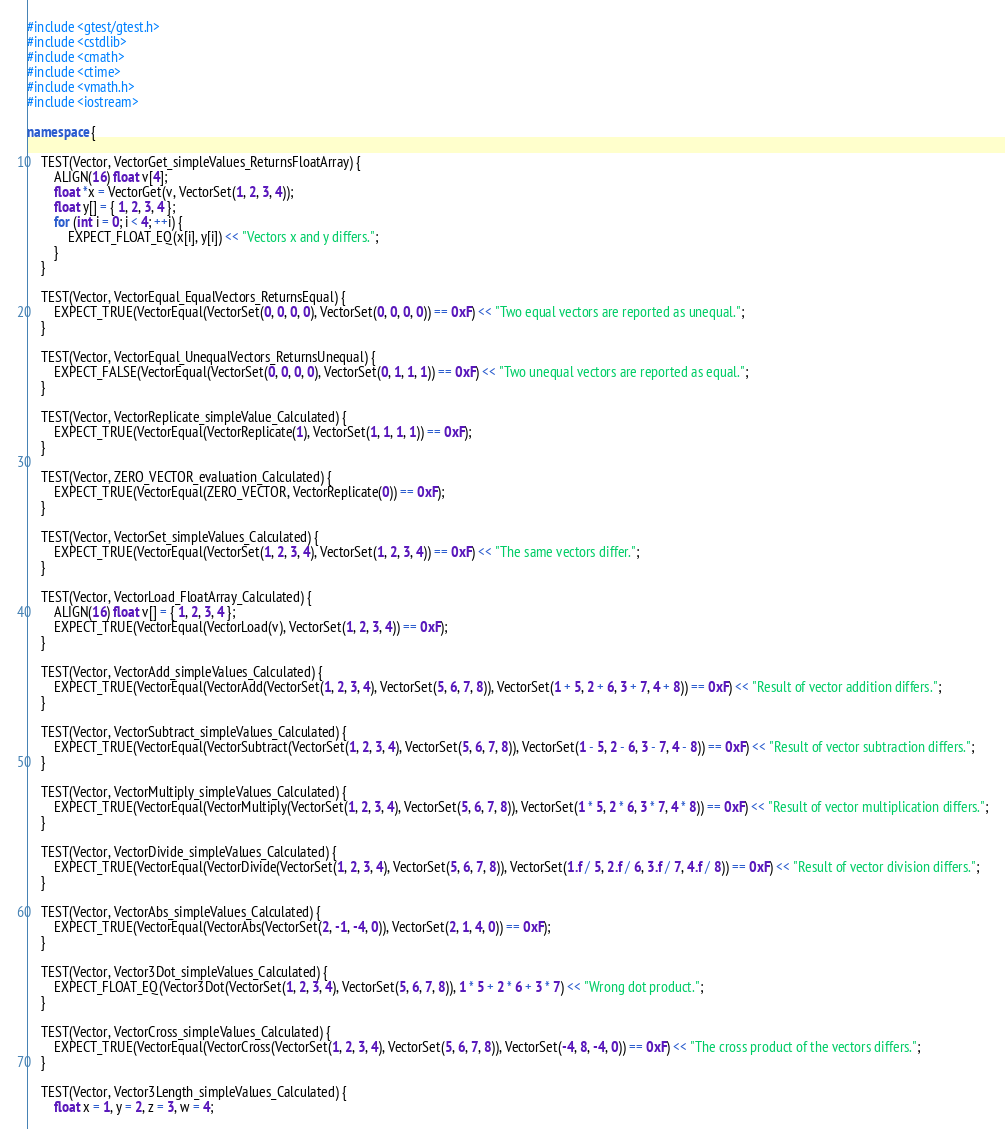Convert code to text. <code><loc_0><loc_0><loc_500><loc_500><_C++_>#include <gtest/gtest.h>
#include <cstdlib>
#include <cmath>
#include <ctime>
#include <vmath.h>
#include <iostream>

namespace {

	TEST(Vector, VectorGet_simpleValues_ReturnsFloatArray) {
		ALIGN(16) float v[4];
		float *x = VectorGet(v, VectorSet(1, 2, 3, 4));
		float y[] = { 1, 2, 3, 4 };
		for (int i = 0; i < 4; ++i) {
			EXPECT_FLOAT_EQ(x[i], y[i]) << "Vectors x and y differs.";
		}
	}

	TEST(Vector, VectorEqual_EqualVectors_ReturnsEqual) {
		EXPECT_TRUE(VectorEqual(VectorSet(0, 0, 0, 0), VectorSet(0, 0, 0, 0)) == 0xF) << "Two equal vectors are reported as unequal.";
	}

	TEST(Vector, VectorEqual_UnequalVectors_ReturnsUnequal) {
		EXPECT_FALSE(VectorEqual(VectorSet(0, 0, 0, 0), VectorSet(0, 1, 1, 1)) == 0xF) << "Two unequal vectors are reported as equal.";
	}

	TEST(Vector, VectorReplicate_simpleValue_Calculated) {
		EXPECT_TRUE(VectorEqual(VectorReplicate(1), VectorSet(1, 1, 1, 1)) == 0xF);
	}

	TEST(Vector, ZERO_VECTOR_evaluation_Calculated) {
		EXPECT_TRUE(VectorEqual(ZERO_VECTOR, VectorReplicate(0)) == 0xF);
	}

	TEST(Vector, VectorSet_simpleValues_Calculated) {
		EXPECT_TRUE(VectorEqual(VectorSet(1, 2, 3, 4), VectorSet(1, 2, 3, 4)) == 0xF) << "The same vectors differ.";
	}

	TEST(Vector, VectorLoad_FloatArray_Calculated) {
		ALIGN(16) float v[] = { 1, 2, 3, 4 };
		EXPECT_TRUE(VectorEqual(VectorLoad(v), VectorSet(1, 2, 3, 4)) == 0xF);
	}

	TEST(Vector, VectorAdd_simpleValues_Calculated) {
		EXPECT_TRUE(VectorEqual(VectorAdd(VectorSet(1, 2, 3, 4), VectorSet(5, 6, 7, 8)), VectorSet(1 + 5, 2 + 6, 3 + 7, 4 + 8)) == 0xF) << "Result of vector addition differs.";
	}

	TEST(Vector, VectorSubtract_simpleValues_Calculated) {
		EXPECT_TRUE(VectorEqual(VectorSubtract(VectorSet(1, 2, 3, 4), VectorSet(5, 6, 7, 8)), VectorSet(1 - 5, 2 - 6, 3 - 7, 4 - 8)) == 0xF) << "Result of vector subtraction differs.";
	}

	TEST(Vector, VectorMultiply_simpleValues_Calculated) {
		EXPECT_TRUE(VectorEqual(VectorMultiply(VectorSet(1, 2, 3, 4), VectorSet(5, 6, 7, 8)), VectorSet(1 * 5, 2 * 6, 3 * 7, 4 * 8)) == 0xF) << "Result of vector multiplication differs.";
	}

	TEST(Vector, VectorDivide_simpleValues_Calculated) {
		EXPECT_TRUE(VectorEqual(VectorDivide(VectorSet(1, 2, 3, 4), VectorSet(5, 6, 7, 8)), VectorSet(1.f / 5, 2.f / 6, 3.f / 7, 4.f / 8)) == 0xF) << "Result of vector division differs.";
	}

	TEST(Vector, VectorAbs_simpleValues_Calculated) {
		EXPECT_TRUE(VectorEqual(VectorAbs(VectorSet(2, -1, -4, 0)), VectorSet(2, 1, 4, 0)) == 0xF);
	}

	TEST(Vector, Vector3Dot_simpleValues_Calculated) {
		EXPECT_FLOAT_EQ(Vector3Dot(VectorSet(1, 2, 3, 4), VectorSet(5, 6, 7, 8)), 1 * 5 + 2 * 6 + 3 * 7) << "Wrong dot product.";
	}

	TEST(Vector, VectorCross_simpleValues_Calculated) {
		EXPECT_TRUE(VectorEqual(VectorCross(VectorSet(1, 2, 3, 4), VectorSet(5, 6, 7, 8)), VectorSet(-4, 8, -4, 0)) == 0xF) << "The cross product of the vectors differs.";
	}

	TEST(Vector, Vector3Length_simpleValues_Calculated) {
		float x = 1, y = 2, z = 3, w = 4;</code> 